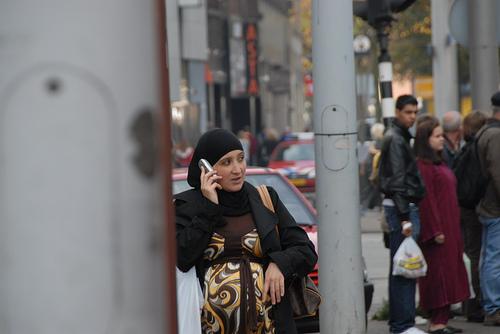Is there anywhere for me to make a phone call?
Give a very brief answer. Yes. What religion does he practice?
Be succinct. Islam. What color is this photo?
Quick response, please. Many colors. What kind of animal do these people spend time with?
Be succinct. Cats. How many people are on their phones?
Concise answer only. 1. What race is the woman?
Keep it brief. Arab. Is alcohol sold here?
Give a very brief answer. No. What are these people waiting for?
Short answer required. Bus. Is this patterned dress typical for Arabic women?
Write a very short answer. Yes. What is the woman talking on?
Short answer required. Cell phone. What does the woman have over her shoulder?
Be succinct. Purse. What color shirts are they wearing?
Give a very brief answer. Black. 